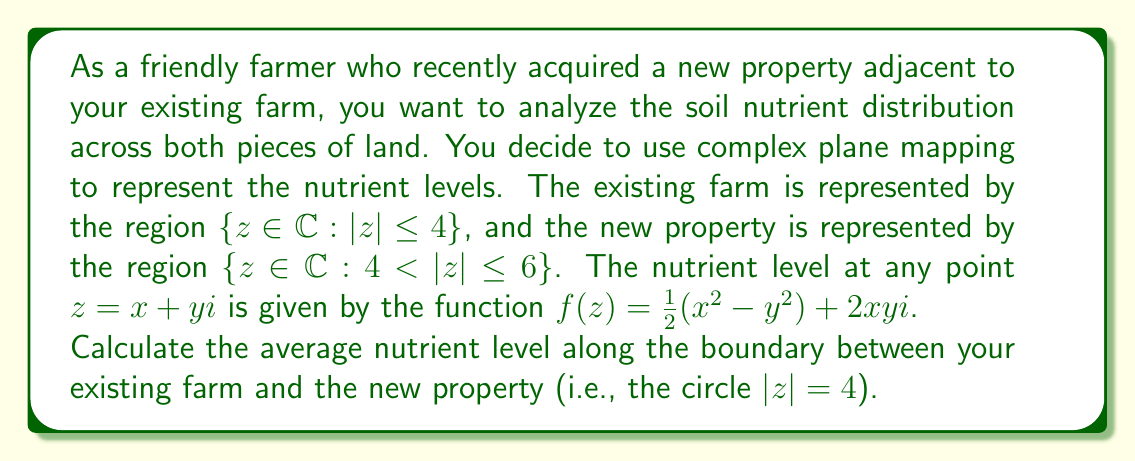Provide a solution to this math problem. To solve this problem, we'll follow these steps:

1) The boundary between the existing farm and the new property is the circle $|z| = 4$. We can parameterize this circle as $z = 4e^{i\theta}$ where $0 \leq \theta < 2\pi$.

2) We need to evaluate $f(z)$ along this circle. Let's substitute $z = 4e^{i\theta} = 4(\cos\theta + i\sin\theta)$ into $f(z)$:

   $f(4e^{i\theta}) = \frac{1}{2}((4\cos\theta)^2 - (4\sin\theta)^2) + 2(4\cos\theta)(4\sin\theta)i$
   
   $= 8(\cos^2\theta - \sin^2\theta) + 32\cos\theta\sin\theta i$
   
   $= 8\cos(2\theta) + 16\sin(2\theta)i$

3) To find the average value, we need to integrate this function over the circle and divide by the circumference:

   $\frac{1}{2\pi} \int_0^{2\pi} f(4e^{i\theta}) d\theta$

4) Let's separate the real and imaginary parts:

   $\frac{1}{2\pi} \int_0^{2\pi} (8\cos(2\theta) + 16\sin(2\theta)i) d\theta$
   
   $= \frac{8}{2\pi} \int_0^{2\pi} \cos(2\theta) d\theta + \frac{16i}{2\pi} \int_0^{2\pi} \sin(2\theta) d\theta$

5) Both of these integrals evaluate to zero over a full period:

   $\int_0^{2\pi} \cos(2\theta) d\theta = \left.\frac{1}{2}\sin(2\theta)\right|_0^{2\pi} = 0$
   
   $\int_0^{2\pi} \sin(2\theta) d\theta = \left.-\frac{1}{2}\cos(2\theta)\right|_0^{2\pi} = 0$

6) Therefore, the average nutrient level along the boundary is zero.
Answer: The average nutrient level along the boundary between the existing farm and the new property is $0$. 